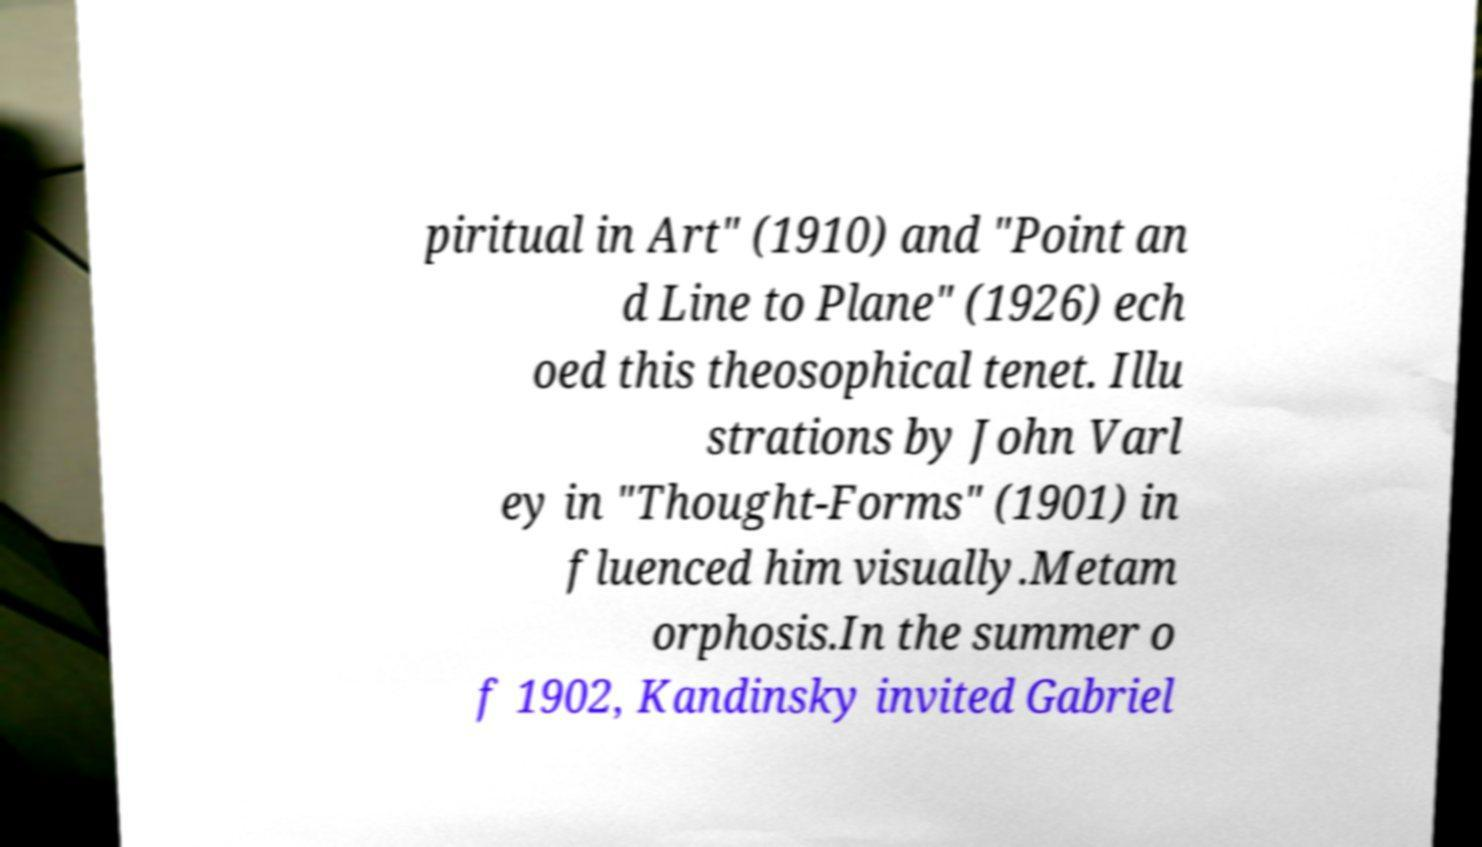There's text embedded in this image that I need extracted. Can you transcribe it verbatim? piritual in Art" (1910) and "Point an d Line to Plane" (1926) ech oed this theosophical tenet. Illu strations by John Varl ey in "Thought-Forms" (1901) in fluenced him visually.Metam orphosis.In the summer o f 1902, Kandinsky invited Gabriel 